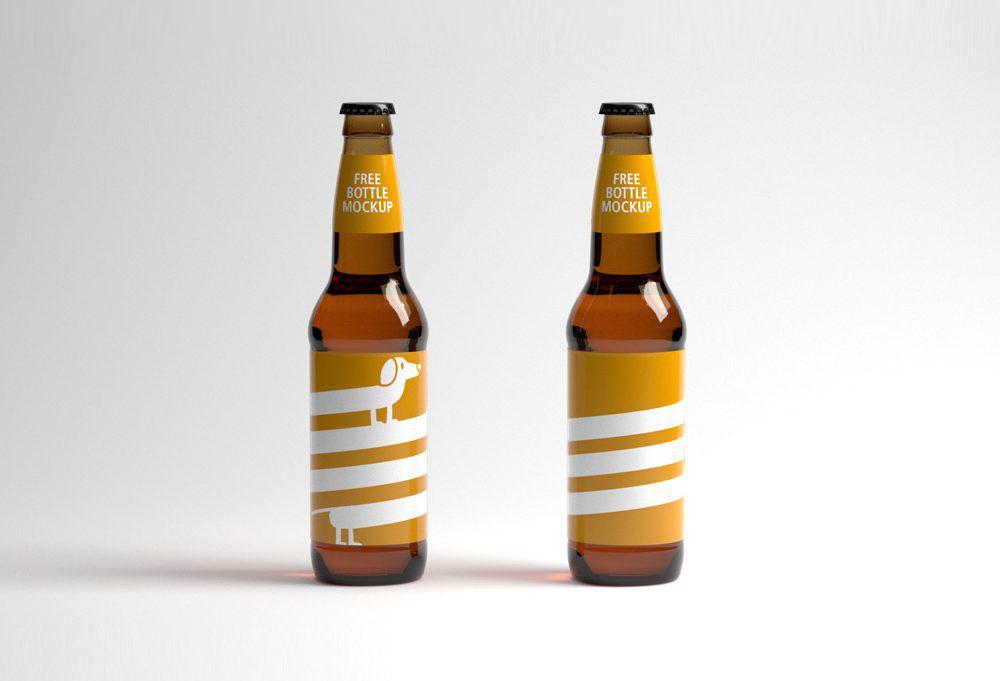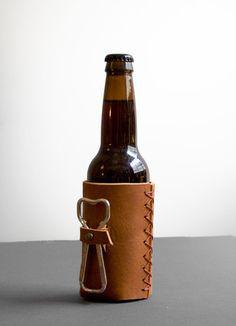The first image is the image on the left, the second image is the image on the right. Examine the images to the left and right. Is the description "There is a green bottle in one of the images." accurate? Answer yes or no. No. The first image is the image on the left, the second image is the image on the right. For the images shown, is this caption "An image shows exactly two bottles, one of them green." true? Answer yes or no. No. The first image is the image on the left, the second image is the image on the right. For the images displayed, is the sentence "There is exactly one green bottle in one of the images." factually correct? Answer yes or no. No. The first image is the image on the left, the second image is the image on the right. Given the left and right images, does the statement "In one image there is one green bottle with one brown bottle" hold true? Answer yes or no. No. 